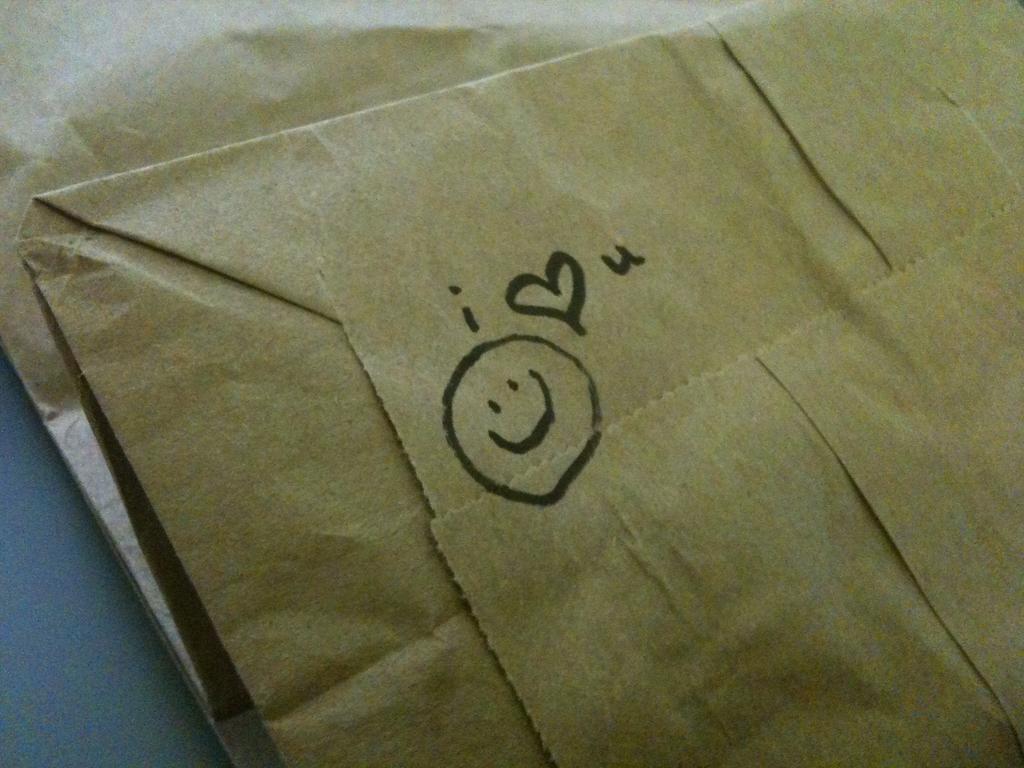What does the person writing the note feel?
Give a very brief answer. Answering does not require reading text in the image. What is the first letter before the heart?
Your answer should be very brief. I. 